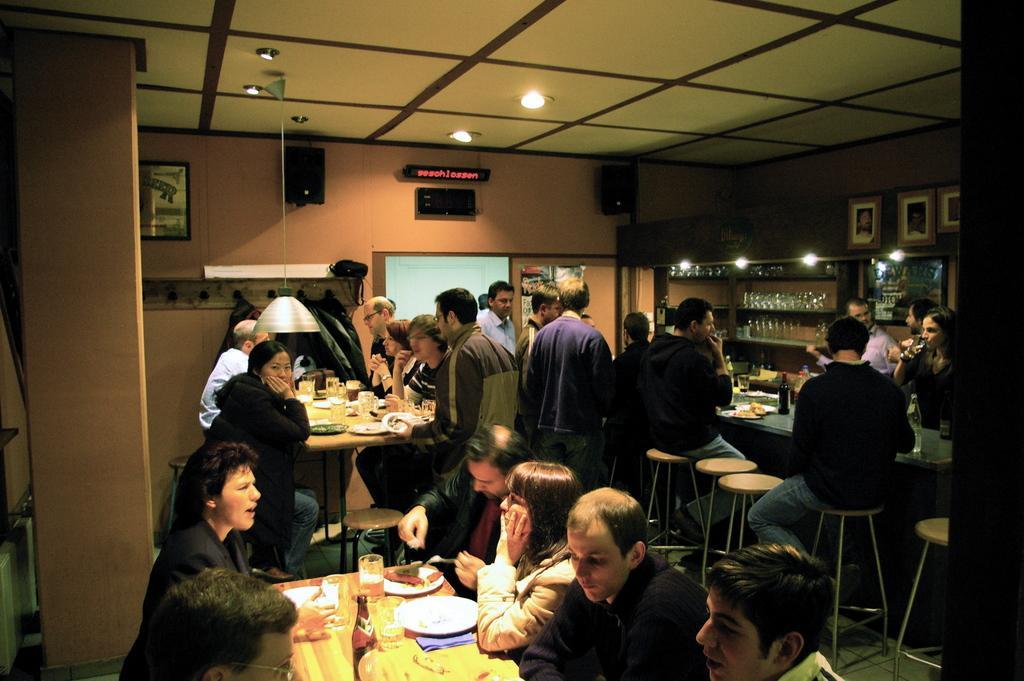Could you give a brief overview of what you see in this image? This image is clicked inside a room. There are many people sitting on the stools at the tables. On the tables there are plates, glasses, bottles and food. To the right there are glasses in the rack. There are picture frames hanging on the wall. In the center there are speakers on the wall. At the there are lights to the ceiling. 